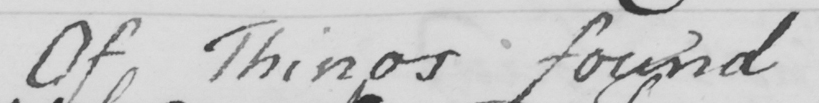Please transcribe the handwritten text in this image. Of Things found 